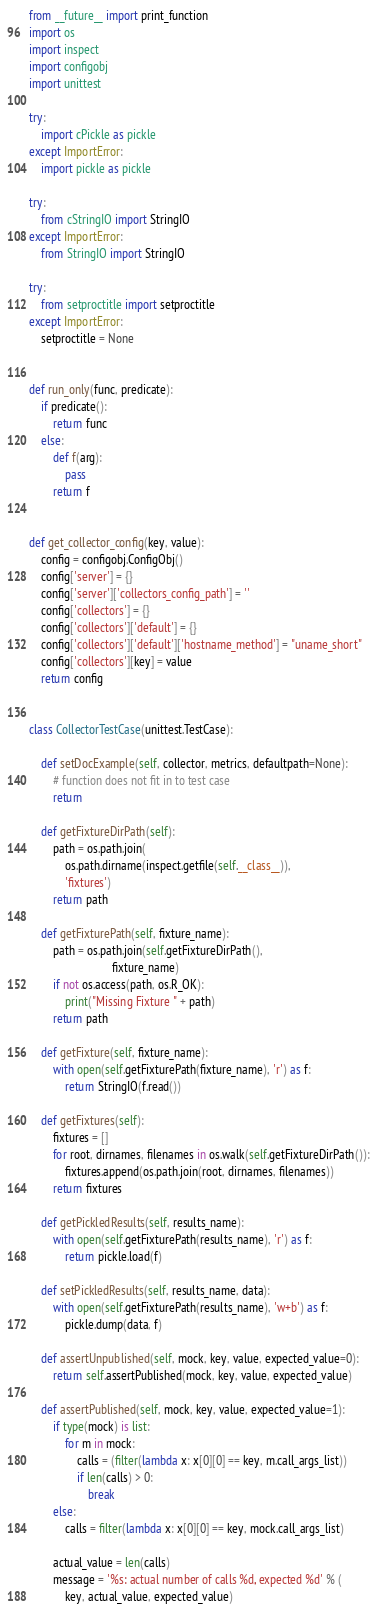<code> <loc_0><loc_0><loc_500><loc_500><_Python_>from __future__ import print_function
import os
import inspect
import configobj
import unittest

try:
    import cPickle as pickle
except ImportError:
    import pickle as pickle

try:
    from cStringIO import StringIO
except ImportError:
    from StringIO import StringIO

try:
    from setproctitle import setproctitle
except ImportError:
    setproctitle = None


def run_only(func, predicate):
    if predicate():
        return func
    else:
        def f(arg):
            pass
        return f


def get_collector_config(key, value):
    config = configobj.ConfigObj()
    config['server'] = {}
    config['server']['collectors_config_path'] = ''
    config['collectors'] = {}
    config['collectors']['default'] = {}
    config['collectors']['default']['hostname_method'] = "uname_short"
    config['collectors'][key] = value
    return config


class CollectorTestCase(unittest.TestCase):

    def setDocExample(self, collector, metrics, defaultpath=None):
        # function does not fit in to test case
        return

    def getFixtureDirPath(self):
        path = os.path.join(
            os.path.dirname(inspect.getfile(self.__class__)),
            'fixtures')
        return path

    def getFixturePath(self, fixture_name):
        path = os.path.join(self.getFixtureDirPath(),
                            fixture_name)
        if not os.access(path, os.R_OK):
            print("Missing Fixture " + path)
        return path

    def getFixture(self, fixture_name):
        with open(self.getFixturePath(fixture_name), 'r') as f:
            return StringIO(f.read())

    def getFixtures(self):
        fixtures = []
        for root, dirnames, filenames in os.walk(self.getFixtureDirPath()):
            fixtures.append(os.path.join(root, dirnames, filenames))
        return fixtures

    def getPickledResults(self, results_name):
        with open(self.getFixturePath(results_name), 'r') as f:
            return pickle.load(f)

    def setPickledResults(self, results_name, data):
        with open(self.getFixturePath(results_name), 'w+b') as f:
            pickle.dump(data, f)

    def assertUnpublished(self, mock, key, value, expected_value=0):
        return self.assertPublished(mock, key, value, expected_value)

    def assertPublished(self, mock, key, value, expected_value=1):
        if type(mock) is list:
            for m in mock:
                calls = (filter(lambda x: x[0][0] == key, m.call_args_list))
                if len(calls) > 0:
                    break
        else:
            calls = filter(lambda x: x[0][0] == key, mock.call_args_list)

        actual_value = len(calls)
        message = '%s: actual number of calls %d, expected %d' % (
            key, actual_value, expected_value)
</code> 